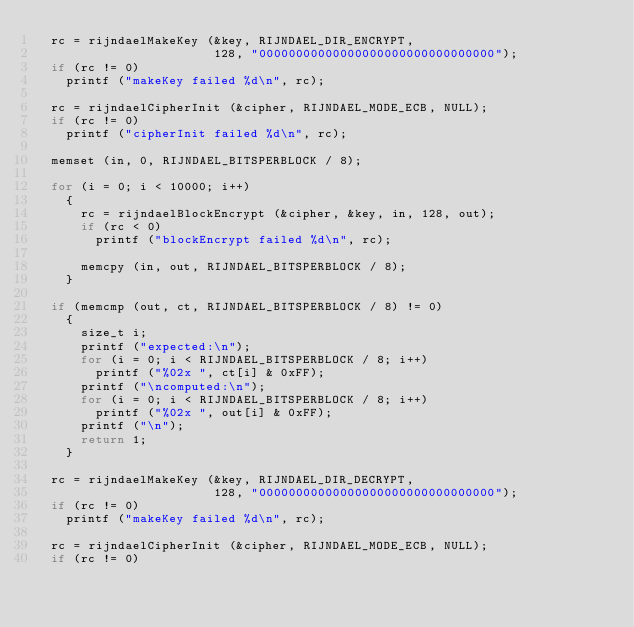Convert code to text. <code><loc_0><loc_0><loc_500><loc_500><_C_>  rc = rijndaelMakeKey (&key, RIJNDAEL_DIR_ENCRYPT,
                        128, "00000000000000000000000000000000");
  if (rc != 0)
    printf ("makeKey failed %d\n", rc);

  rc = rijndaelCipherInit (&cipher, RIJNDAEL_MODE_ECB, NULL);
  if (rc != 0)
    printf ("cipherInit failed %d\n", rc);

  memset (in, 0, RIJNDAEL_BITSPERBLOCK / 8);

  for (i = 0; i < 10000; i++)
    {
      rc = rijndaelBlockEncrypt (&cipher, &key, in, 128, out);
      if (rc < 0)
        printf ("blockEncrypt failed %d\n", rc);

      memcpy (in, out, RIJNDAEL_BITSPERBLOCK / 8);
    }

  if (memcmp (out, ct, RIJNDAEL_BITSPERBLOCK / 8) != 0)
    {
      size_t i;
      printf ("expected:\n");
      for (i = 0; i < RIJNDAEL_BITSPERBLOCK / 8; i++)
        printf ("%02x ", ct[i] & 0xFF);
      printf ("\ncomputed:\n");
      for (i = 0; i < RIJNDAEL_BITSPERBLOCK / 8; i++)
        printf ("%02x ", out[i] & 0xFF);
      printf ("\n");
      return 1;
    }

  rc = rijndaelMakeKey (&key, RIJNDAEL_DIR_DECRYPT,
                        128, "00000000000000000000000000000000");
  if (rc != 0)
    printf ("makeKey failed %d\n", rc);

  rc = rijndaelCipherInit (&cipher, RIJNDAEL_MODE_ECB, NULL);
  if (rc != 0)</code> 